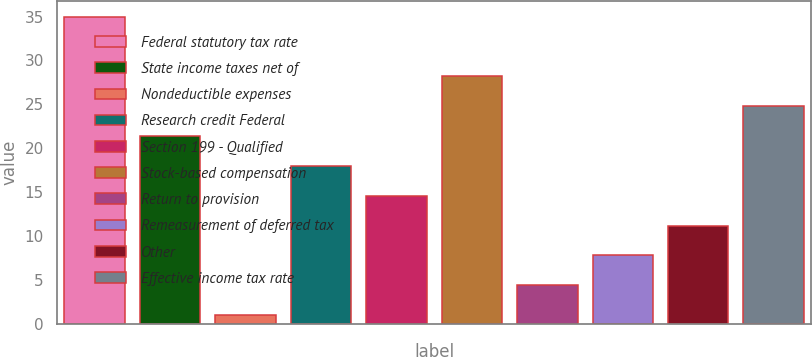<chart> <loc_0><loc_0><loc_500><loc_500><bar_chart><fcel>Federal statutory tax rate<fcel>State income taxes net of<fcel>Nondeductible expenses<fcel>Research credit Federal<fcel>Section 199 - Qualified<fcel>Stock-based compensation<fcel>Return to provision<fcel>Remeasurement of deferred tax<fcel>Other<fcel>Effective income tax rate<nl><fcel>35<fcel>21.4<fcel>1<fcel>18<fcel>14.6<fcel>28.2<fcel>4.4<fcel>7.8<fcel>11.2<fcel>24.8<nl></chart> 